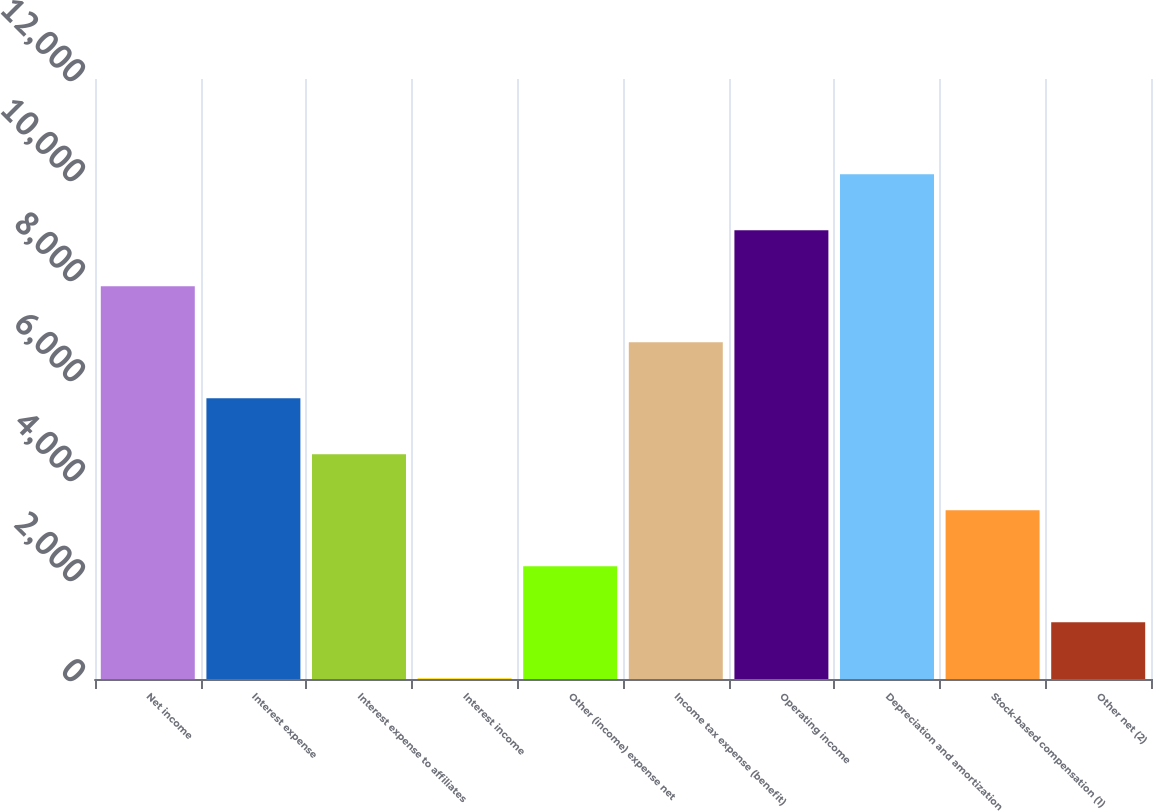Convert chart. <chart><loc_0><loc_0><loc_500><loc_500><bar_chart><fcel>Net income<fcel>Interest expense<fcel>Interest expense to affiliates<fcel>Interest income<fcel>Other (income) expense net<fcel>Income tax expense (benefit)<fcel>Operating income<fcel>Depreciation and amortization<fcel>Stock-based compensation (1)<fcel>Other net (2)<nl><fcel>7854.2<fcel>5615<fcel>4495.4<fcel>17<fcel>2256.2<fcel>6734.6<fcel>8973.8<fcel>10093.4<fcel>3375.8<fcel>1136.6<nl></chart> 